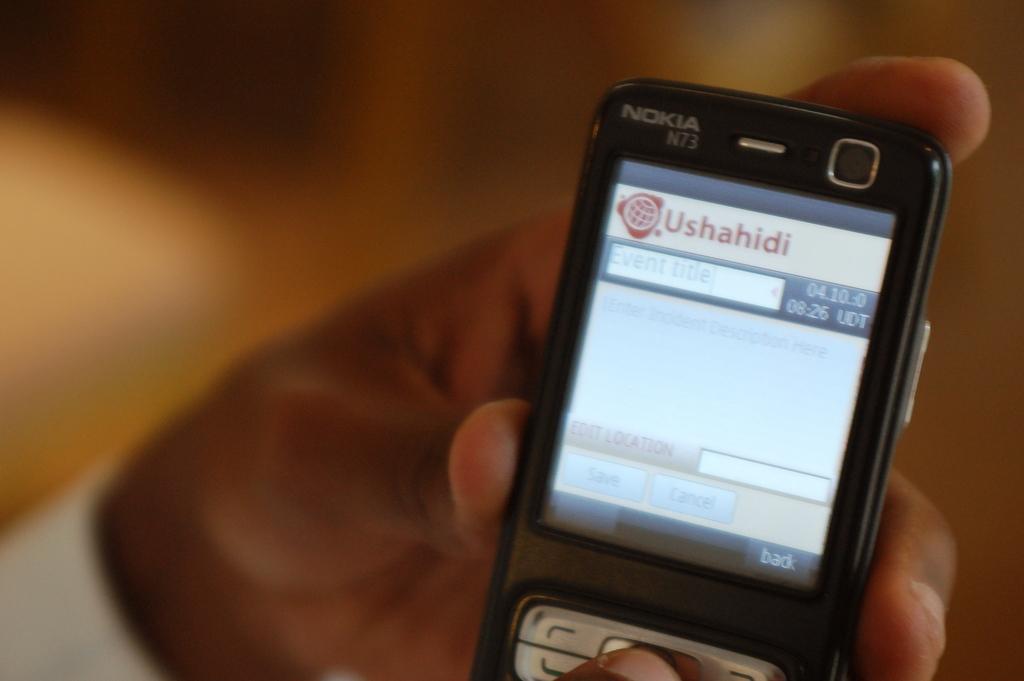Who made this phone?
Provide a short and direct response. Nokia. What us the time?
Give a very brief answer. 8:26. 